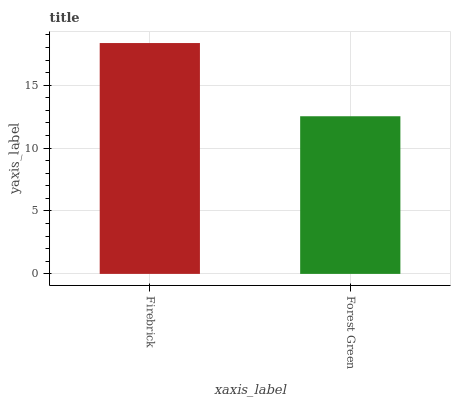Is Forest Green the minimum?
Answer yes or no. Yes. Is Firebrick the maximum?
Answer yes or no. Yes. Is Forest Green the maximum?
Answer yes or no. No. Is Firebrick greater than Forest Green?
Answer yes or no. Yes. Is Forest Green less than Firebrick?
Answer yes or no. Yes. Is Forest Green greater than Firebrick?
Answer yes or no. No. Is Firebrick less than Forest Green?
Answer yes or no. No. Is Firebrick the high median?
Answer yes or no. Yes. Is Forest Green the low median?
Answer yes or no. Yes. Is Forest Green the high median?
Answer yes or no. No. Is Firebrick the low median?
Answer yes or no. No. 